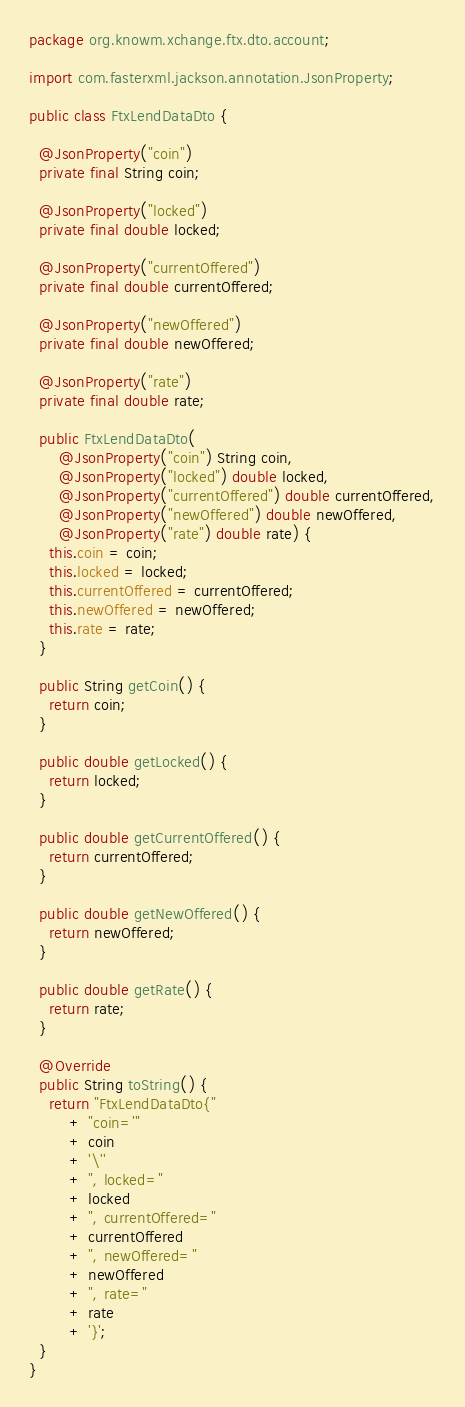Convert code to text. <code><loc_0><loc_0><loc_500><loc_500><_Java_>package org.knowm.xchange.ftx.dto.account;

import com.fasterxml.jackson.annotation.JsonProperty;

public class FtxLendDataDto {

  @JsonProperty("coin")
  private final String coin;

  @JsonProperty("locked")
  private final double locked;

  @JsonProperty("currentOffered")
  private final double currentOffered;

  @JsonProperty("newOffered")
  private final double newOffered;

  @JsonProperty("rate")
  private final double rate;

  public FtxLendDataDto(
      @JsonProperty("coin") String coin,
      @JsonProperty("locked") double locked,
      @JsonProperty("currentOffered") double currentOffered,
      @JsonProperty("newOffered") double newOffered,
      @JsonProperty("rate") double rate) {
    this.coin = coin;
    this.locked = locked;
    this.currentOffered = currentOffered;
    this.newOffered = newOffered;
    this.rate = rate;
  }

  public String getCoin() {
    return coin;
  }

  public double getLocked() {
    return locked;
  }

  public double getCurrentOffered() {
    return currentOffered;
  }

  public double getNewOffered() {
    return newOffered;
  }

  public double getRate() {
    return rate;
  }

  @Override
  public String toString() {
    return "FtxLendDataDto{"
        + "coin='"
        + coin
        + '\''
        + ", locked="
        + locked
        + ", currentOffered="
        + currentOffered
        + ", newOffered="
        + newOffered
        + ", rate="
        + rate
        + '}';
  }
}
</code> 